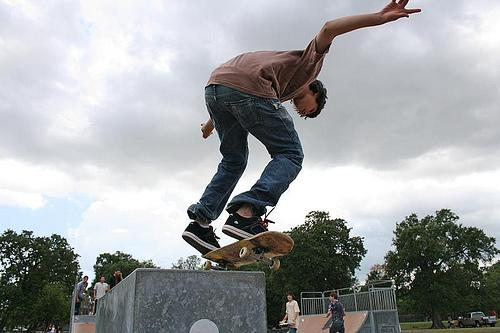What is the best material for a skateboard? Please explain your reasoning. maple. Its not soft and its light. 